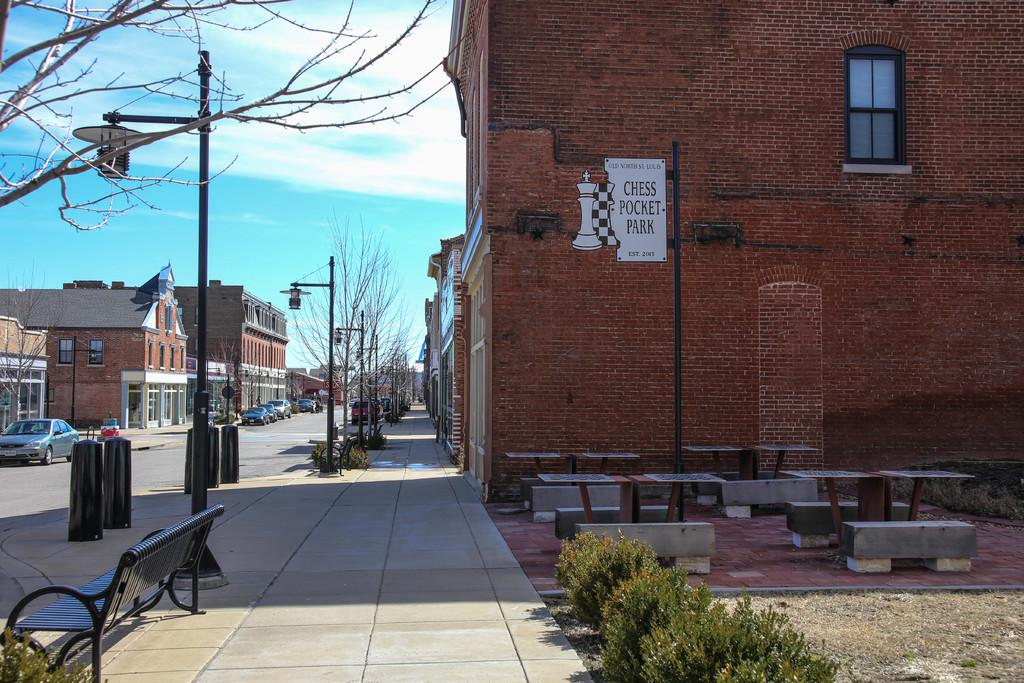What type of objects can be seen in the image? There are plants, benches, tables, poles, and a poster on a wall in the image. What structures are visible in the background of the image? There are buildings and vehicles on the road in the background of the image. What type of vegetation can be seen in the background of the image? There are dried trees in the background of the image. What is visible in the sky in the image? The sky is visible in the background of the image, and there are clouds in the sky. What type of linen is draped over the benches in the image? There is no linen draped over the benches in the image. What type of mine is visible in the background of the image? There is no mine present in the image; it features buildings and vehicles on the road in the background. 